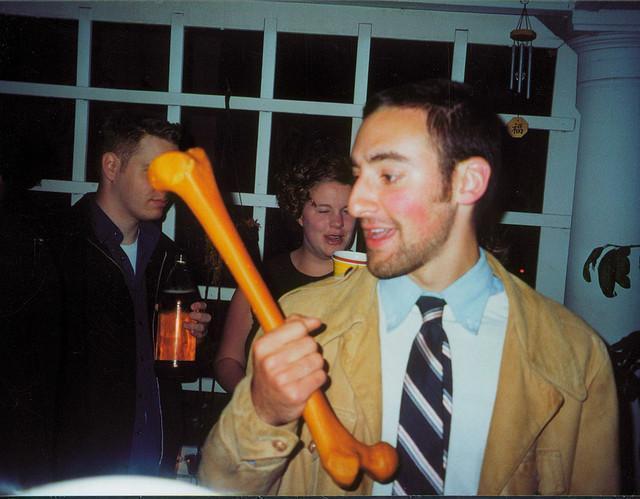What is the orange object called?
Make your selection and explain in format: 'Answer: answer
Rationale: rationale.'
Options: Bone, hammer, bat, sickle. Answer: bone.
Rationale: The man is holding an orange bone in his hand. 